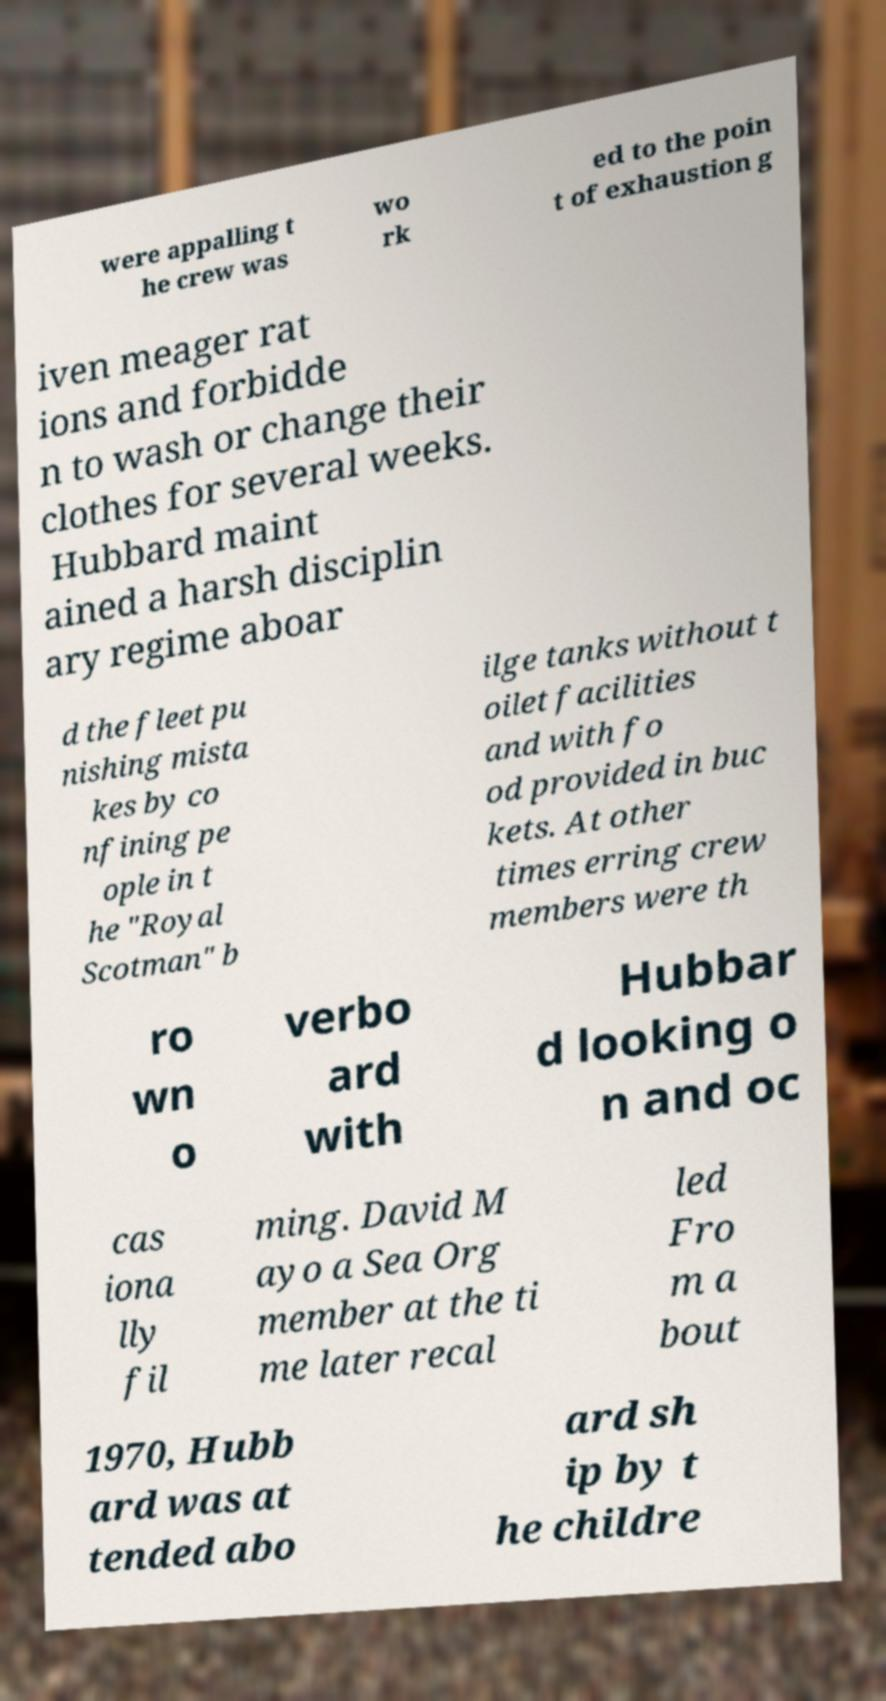I need the written content from this picture converted into text. Can you do that? were appalling t he crew was wo rk ed to the poin t of exhaustion g iven meager rat ions and forbidde n to wash or change their clothes for several weeks. Hubbard maint ained a harsh disciplin ary regime aboar d the fleet pu nishing mista kes by co nfining pe ople in t he "Royal Scotman" b ilge tanks without t oilet facilities and with fo od provided in buc kets. At other times erring crew members were th ro wn o verbo ard with Hubbar d looking o n and oc cas iona lly fil ming. David M ayo a Sea Org member at the ti me later recal led Fro m a bout 1970, Hubb ard was at tended abo ard sh ip by t he childre 